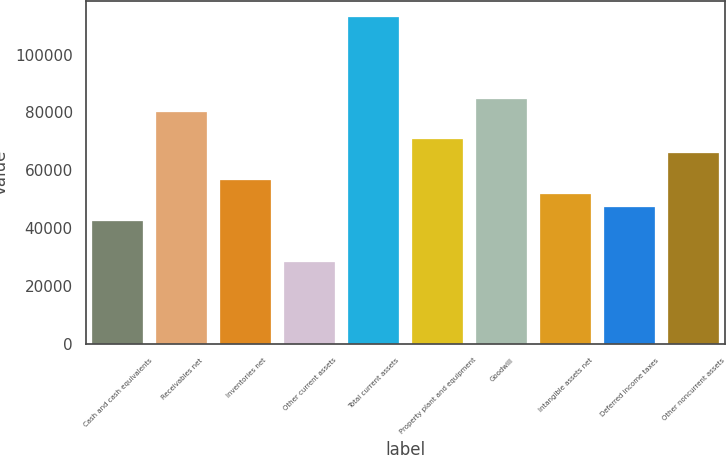Convert chart. <chart><loc_0><loc_0><loc_500><loc_500><bar_chart><fcel>Cash and cash equivalents<fcel>Receivables net<fcel>Inventories net<fcel>Other current assets<fcel>Total current assets<fcel>Property plant and equipment<fcel>Goodwill<fcel>Intangible assets net<fcel>Deferred income taxes<fcel>Other noncurrent assets<nl><fcel>42424.4<fcel>80069.2<fcel>56541.2<fcel>28307.6<fcel>113008<fcel>70658<fcel>84774.8<fcel>51835.6<fcel>47130<fcel>65952.4<nl></chart> 